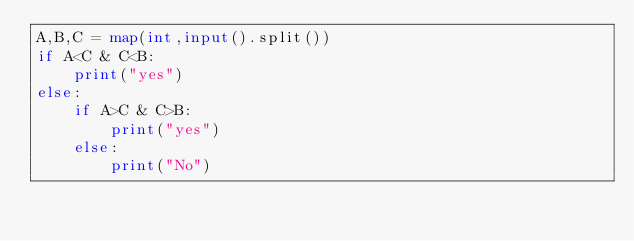Convert code to text. <code><loc_0><loc_0><loc_500><loc_500><_Python_>A,B,C = map(int,input().split())
if A<C & C<B:
	print("yes")
else:
	if A>C & C>B:
   		print("yes")
	else:
		print("No")</code> 